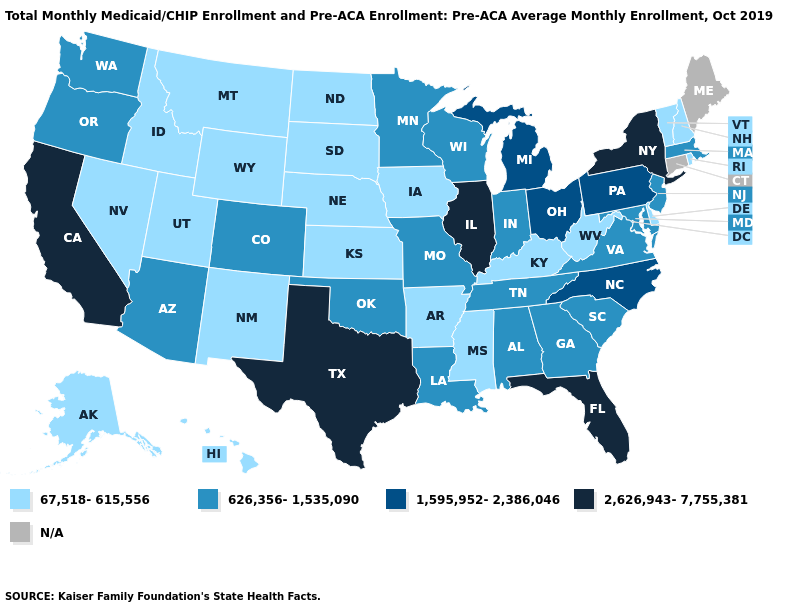What is the highest value in the USA?
Concise answer only. 2,626,943-7,755,381. How many symbols are there in the legend?
Give a very brief answer. 5. What is the value of Ohio?
Quick response, please. 1,595,952-2,386,046. What is the highest value in the USA?
Be succinct. 2,626,943-7,755,381. Which states have the highest value in the USA?
Concise answer only. California, Florida, Illinois, New York, Texas. Which states have the highest value in the USA?
Write a very short answer. California, Florida, Illinois, New York, Texas. Is the legend a continuous bar?
Concise answer only. No. What is the lowest value in the USA?
Answer briefly. 67,518-615,556. Which states have the lowest value in the USA?
Keep it brief. Alaska, Arkansas, Delaware, Hawaii, Idaho, Iowa, Kansas, Kentucky, Mississippi, Montana, Nebraska, Nevada, New Hampshire, New Mexico, North Dakota, Rhode Island, South Dakota, Utah, Vermont, West Virginia, Wyoming. What is the value of Rhode Island?
Answer briefly. 67,518-615,556. Name the states that have a value in the range 2,626,943-7,755,381?
Concise answer only. California, Florida, Illinois, New York, Texas. Name the states that have a value in the range 67,518-615,556?
Give a very brief answer. Alaska, Arkansas, Delaware, Hawaii, Idaho, Iowa, Kansas, Kentucky, Mississippi, Montana, Nebraska, Nevada, New Hampshire, New Mexico, North Dakota, Rhode Island, South Dakota, Utah, Vermont, West Virginia, Wyoming. Name the states that have a value in the range 67,518-615,556?
Answer briefly. Alaska, Arkansas, Delaware, Hawaii, Idaho, Iowa, Kansas, Kentucky, Mississippi, Montana, Nebraska, Nevada, New Hampshire, New Mexico, North Dakota, Rhode Island, South Dakota, Utah, Vermont, West Virginia, Wyoming. Does Virginia have the lowest value in the USA?
Write a very short answer. No. 